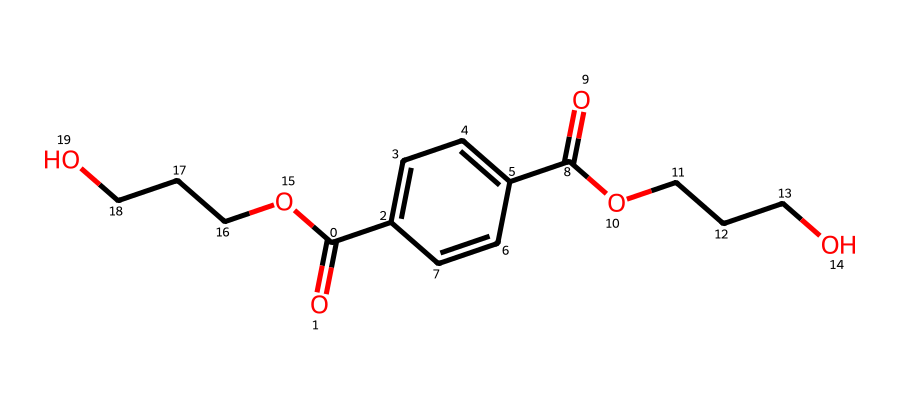What is the molecular formula of this compound? The molecular formula can be derived from the SMILES notation by counting the number of each type of atom present. In the SMILES, there are 10 carbons (C), 10 hydrogens (H), 4 oxygens (O), resulting in C10H10O4.
Answer: C10H10O4 How many carbon atoms are present in this molecular structure? By analyzing the SMILES, there are ten 'C' characters that represent carbon atoms.
Answer: 10 What functional groups are present in this molecule? The SMILES indicates the presence of ester (from the -OCCCO part) and carboxylic acid groups (indicated by the -C(=O)O part). Both functional groups are typical in polyesters like PET.
Answer: ester and carboxylic acid What type of polymer is this compound classified as? Based on its structure and the presence of repeating ester linkages, this compound is classified as a polyester.
Answer: polyester How many oxygen atoms are in this molecular structure? In the SMILES representation, there are 4 'O' characters indicating the presence of four oxygen atoms.
Answer: 4 Is this compound biodegradable? Given that PET is generally known for its durability and resistance to biodegradation in natural environments, this compound is not typically considered biodegradable.
Answer: not biodegradable 